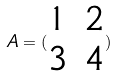<formula> <loc_0><loc_0><loc_500><loc_500>A = ( \begin{matrix} 1 & 2 \\ 3 & 4 \end{matrix} )</formula> 